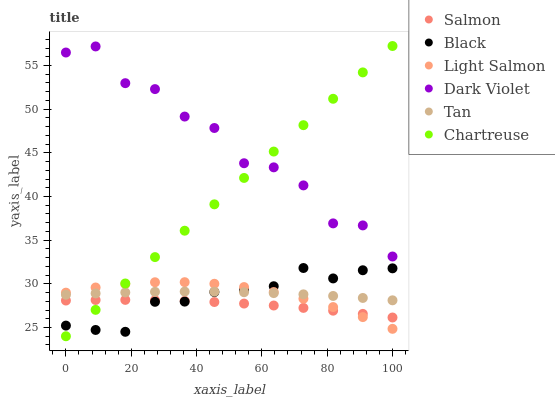Does Salmon have the minimum area under the curve?
Answer yes or no. Yes. Does Dark Violet have the maximum area under the curve?
Answer yes or no. Yes. Does Dark Violet have the minimum area under the curve?
Answer yes or no. No. Does Salmon have the maximum area under the curve?
Answer yes or no. No. Is Chartreuse the smoothest?
Answer yes or no. Yes. Is Dark Violet the roughest?
Answer yes or no. Yes. Is Salmon the smoothest?
Answer yes or no. No. Is Salmon the roughest?
Answer yes or no. No. Does Chartreuse have the lowest value?
Answer yes or no. Yes. Does Salmon have the lowest value?
Answer yes or no. No. Does Chartreuse have the highest value?
Answer yes or no. Yes. Does Dark Violet have the highest value?
Answer yes or no. No. Is Light Salmon less than Dark Violet?
Answer yes or no. Yes. Is Tan greater than Salmon?
Answer yes or no. Yes. Does Chartreuse intersect Black?
Answer yes or no. Yes. Is Chartreuse less than Black?
Answer yes or no. No. Is Chartreuse greater than Black?
Answer yes or no. No. Does Light Salmon intersect Dark Violet?
Answer yes or no. No. 